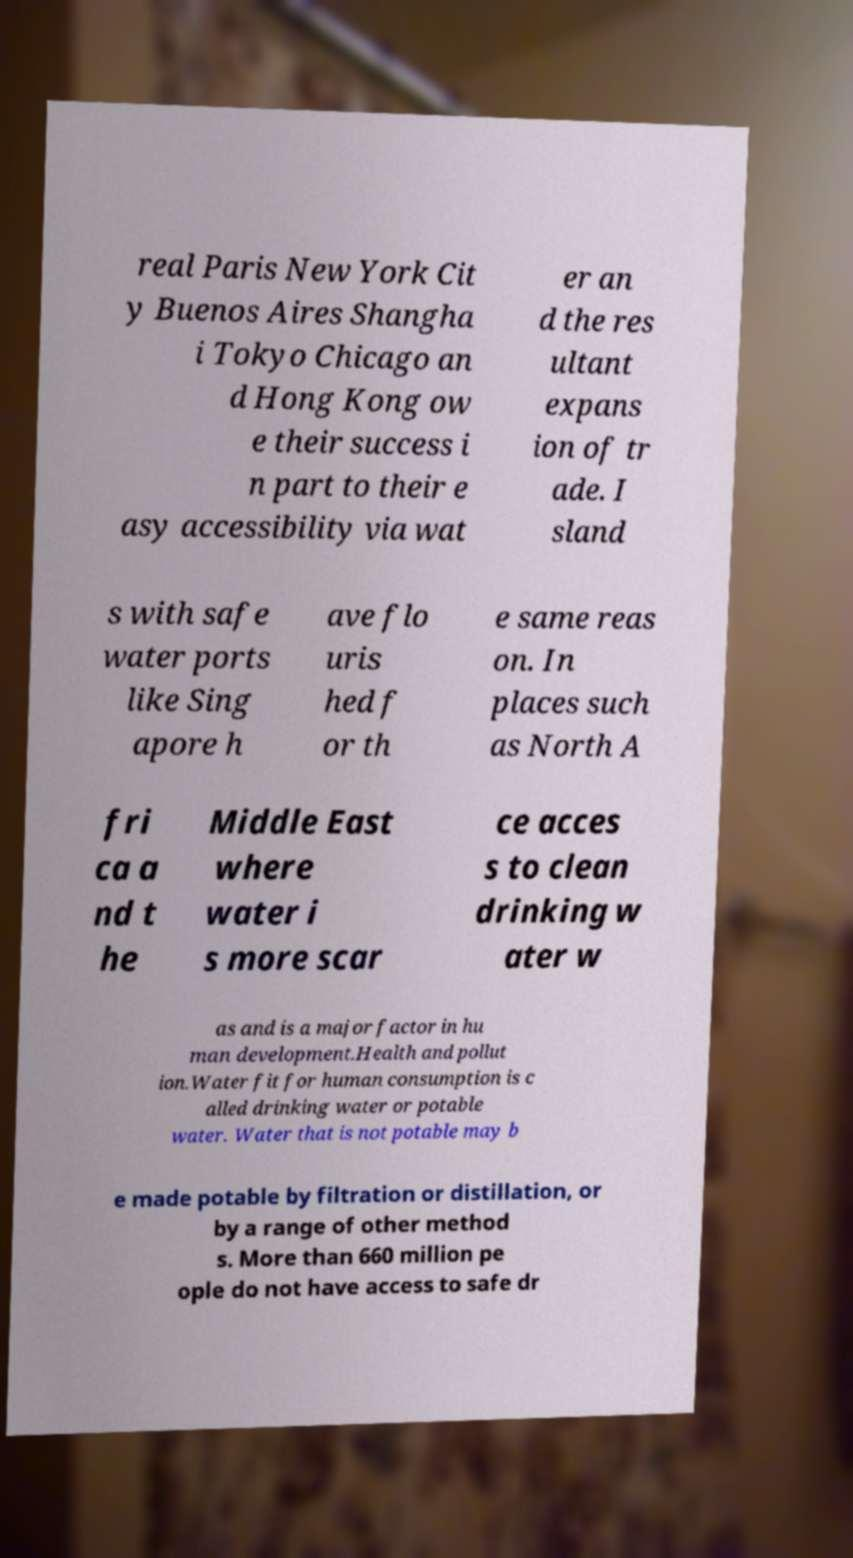Could you extract and type out the text from this image? real Paris New York Cit y Buenos Aires Shangha i Tokyo Chicago an d Hong Kong ow e their success i n part to their e asy accessibility via wat er an d the res ultant expans ion of tr ade. I sland s with safe water ports like Sing apore h ave flo uris hed f or th e same reas on. In places such as North A fri ca a nd t he Middle East where water i s more scar ce acces s to clean drinking w ater w as and is a major factor in hu man development.Health and pollut ion.Water fit for human consumption is c alled drinking water or potable water. Water that is not potable may b e made potable by filtration or distillation, or by a range of other method s. More than 660 million pe ople do not have access to safe dr 